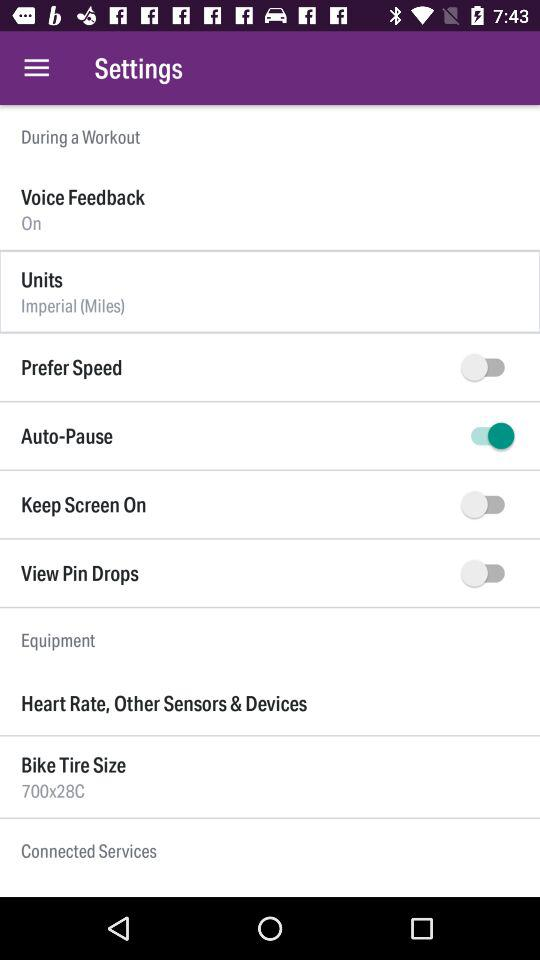What is the selected unit? The selected unit is "Imperial (MiIes)". 